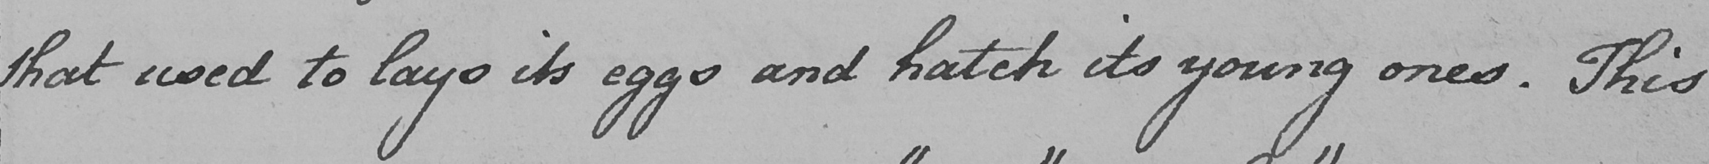What is written in this line of handwriting? that used to lays its eggs and hatch its young ones . This 